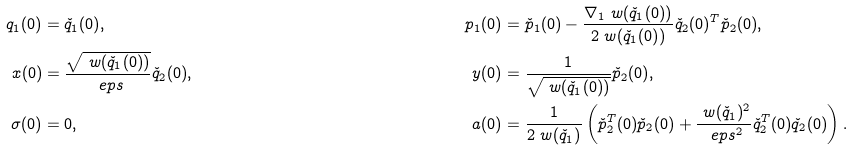<formula> <loc_0><loc_0><loc_500><loc_500>q _ { 1 } ( 0 ) & = \check { q } _ { 1 } ( 0 ) , & p _ { 1 } ( 0 ) & = \check { p } _ { 1 } ( 0 ) - \frac { \nabla _ { 1 } \ w ( \check { q } _ { 1 } ( 0 ) ) } { 2 \ w ( \check { q } _ { 1 } ( 0 ) ) } \check { q } _ { 2 } ( 0 ) ^ { T } \check { p } _ { 2 } ( 0 ) , \\ x ( 0 ) & = \frac { \sqrt { \ w ( \check { q } _ { 1 } ( 0 ) ) } } { \ e p s } \check { q } _ { 2 } ( 0 ) , & y ( 0 ) & = \frac { 1 } { \sqrt { \ w ( \check { q } _ { 1 } ( 0 ) ) } } \check { p } _ { 2 } ( 0 ) , \\ \sigma ( 0 ) & = 0 , & a ( 0 ) & = \frac { 1 } { 2 \ w ( \check { q } _ { 1 } ) } \left ( \check { p } _ { 2 } ^ { T } ( 0 ) \check { p } _ { 2 } ( 0 ) + \frac { \ w ( \check { q } _ { 1 } ) ^ { 2 } } { \ e p s ^ { 2 } } \check { q } _ { 2 } ^ { T } ( 0 ) \check { q } _ { 2 } ( 0 ) \right ) .</formula> 